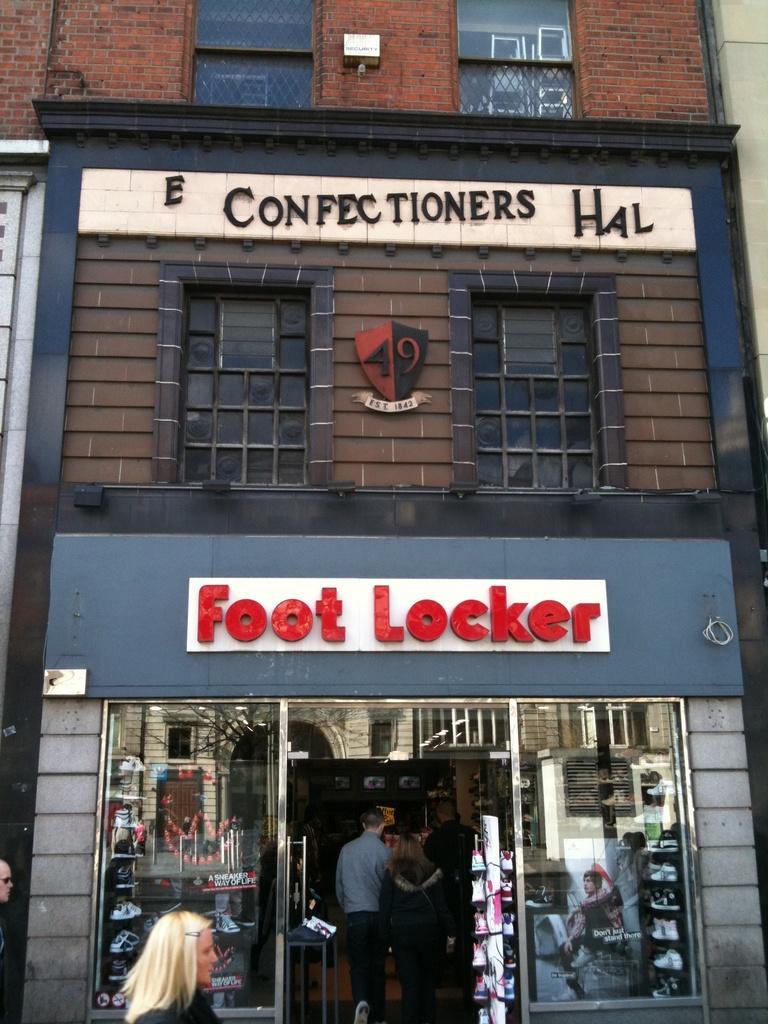What is the main structure in the center of the image? There is a building in the center of the image. What can be seen at the bottom of the image? There are persons visible at the bottom of the image, and there is also a store. How many visitors are waiting at the harbor in the image? There is no harbor or visitors present in the image. What type of apparel is being sold in the store at the bottom of the image? The image does not provide information about the type of apparel being sold in the store. 